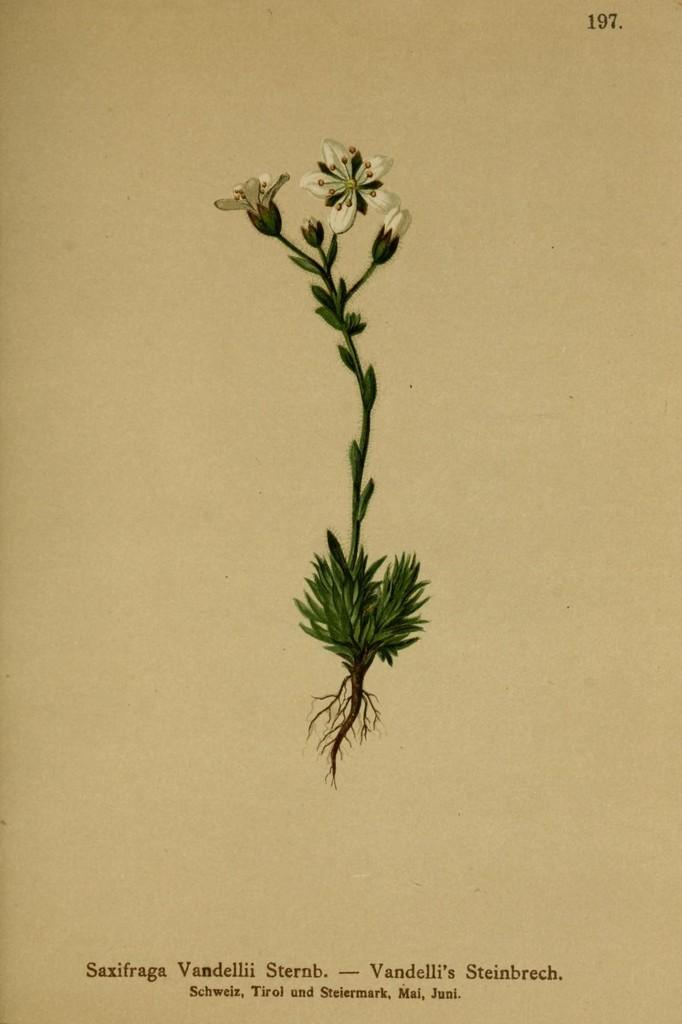What is the main subject of the image? There is a plant in the image. What is the plant placed on? The plant is on a paper. What type of flowers are on the plant? There are white color flowers on the plant. What is the color of the background in the image? The background of the image is in cream color. Is there any text visible in the image? Yes, there is some text visible in the image. Can you see any birds flying over the hill in the image? There is no hill or birds present in the image; it features a plant on a paper with white flowers. 